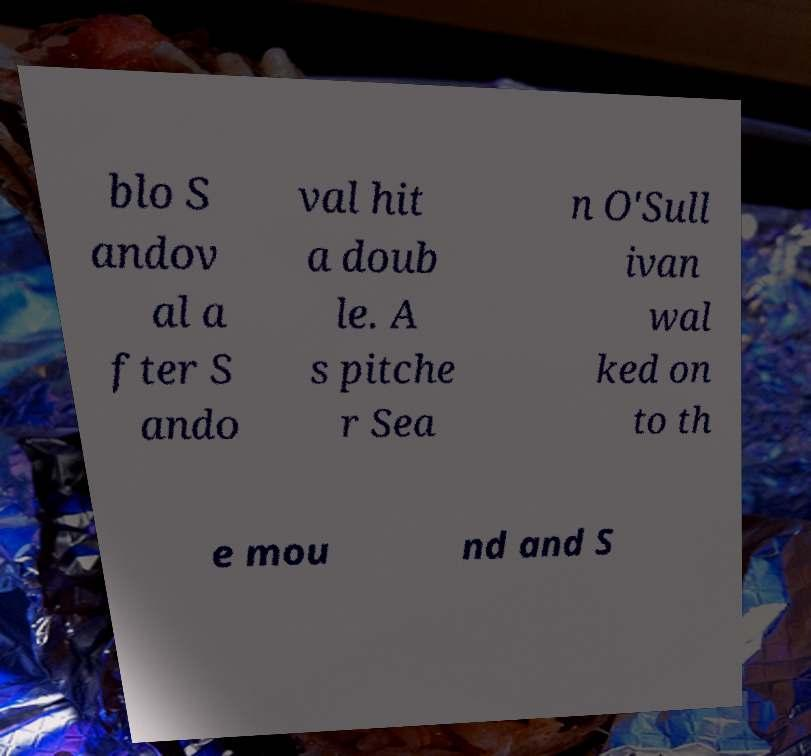Can you accurately transcribe the text from the provided image for me? blo S andov al a fter S ando val hit a doub le. A s pitche r Sea n O'Sull ivan wal ked on to th e mou nd and S 